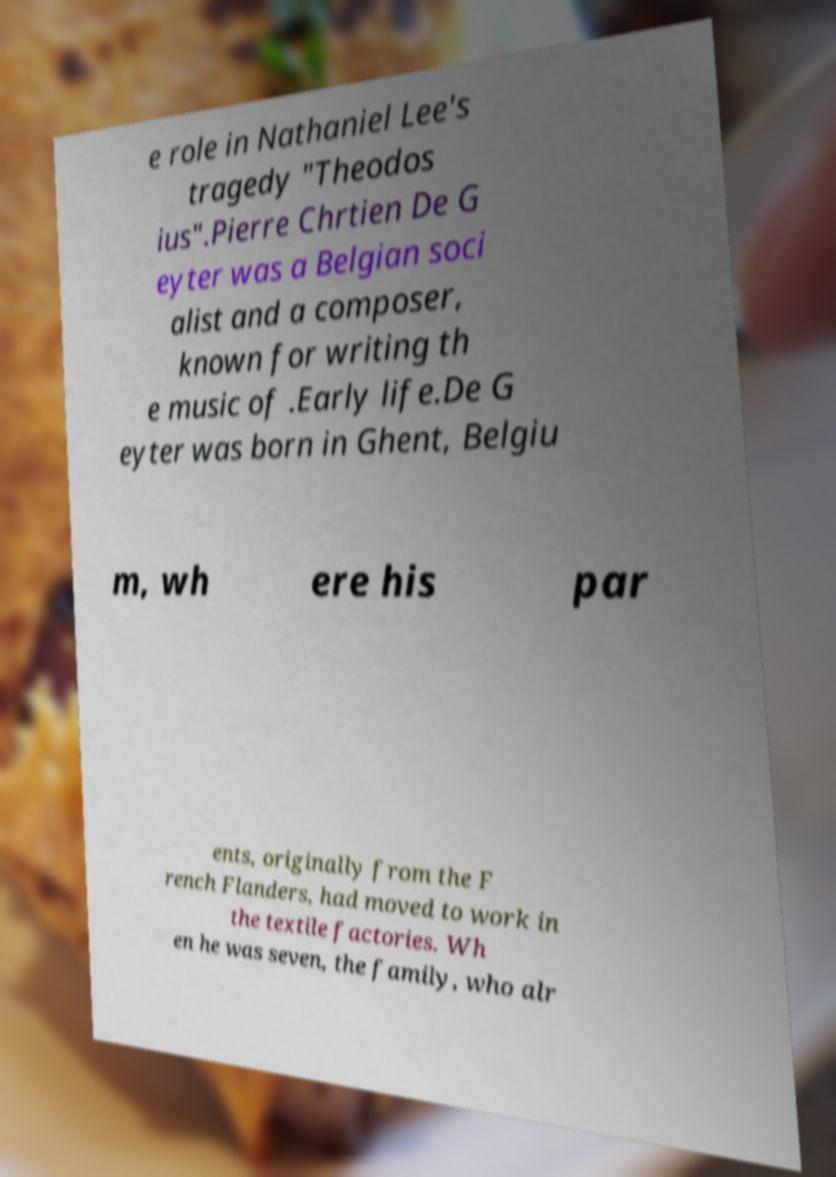For documentation purposes, I need the text within this image transcribed. Could you provide that? e role in Nathaniel Lee's tragedy "Theodos ius".Pierre Chrtien De G eyter was a Belgian soci alist and a composer, known for writing th e music of .Early life.De G eyter was born in Ghent, Belgiu m, wh ere his par ents, originally from the F rench Flanders, had moved to work in the textile factories. Wh en he was seven, the family, who alr 